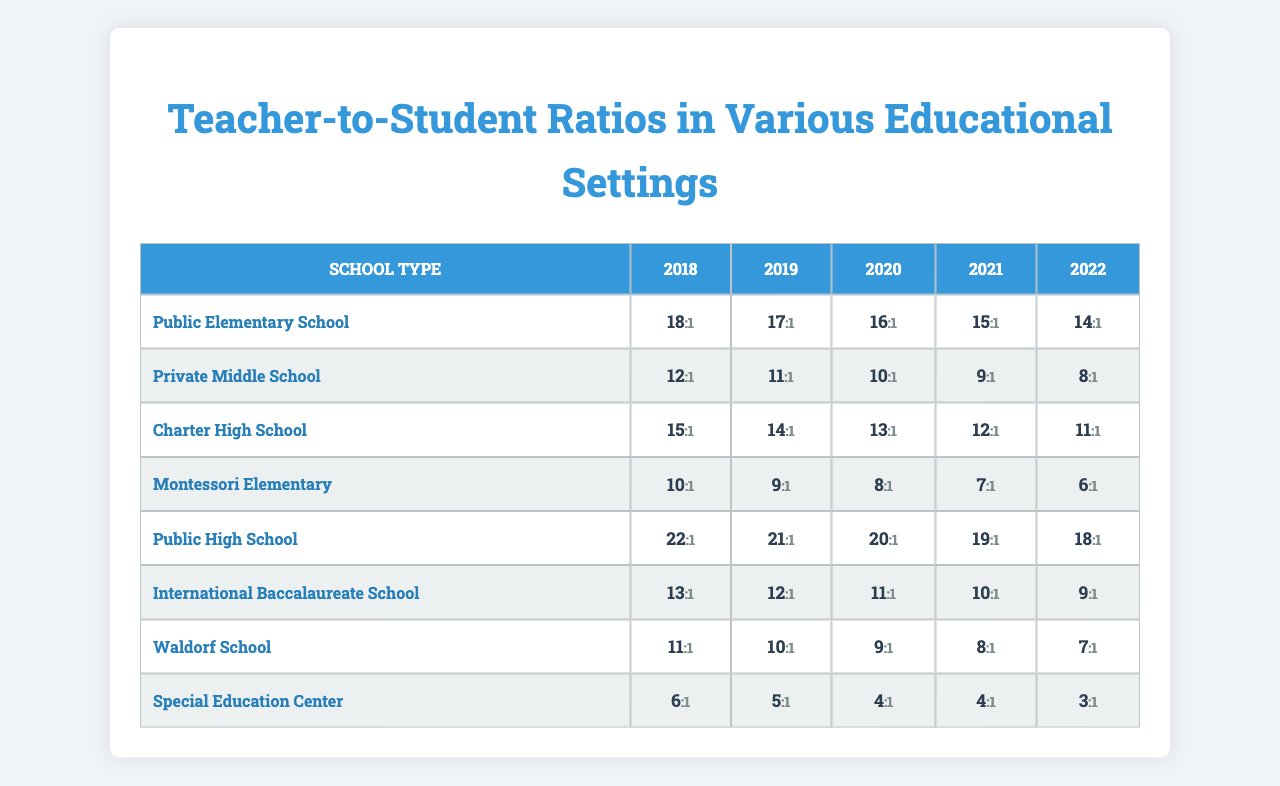What is the teacher-to-student ratio for Public Elementary Schools in 2022? From the table, the ratio for Public Elementary Schools in 2022 is found by looking at the 2022 column for that school type. The value is 14.
Answer: 14 What is the lowest teacher-to-student ratio reported in 2018? To find the lowest ratio in 2018, we look at the first column of ratios for all school types. The lowest value in that column is 6 for the Special Education Center.
Answer: 6 Which school type had the highest teacher-to-student ratio in 2021? In the 2021 column, we compare ratios across all school types. The highest value is 22 for the Public High School.
Answer: Public High School What is the average teacher-to-student ratio for Charter High Schools over the five years? The ratios for Charter High Schools are [15, 14, 13, 12, 11]. We calculate the average by summing these values (15 + 14 + 13 + 12 + 11 = 65) and dividing by the number of years (65/5 = 13).
Answer: 13 Is the teacher-to-student ratio for Montessori Elementary Schools improving from 2018 to 2022? The ratios over the years for Montessori Elementary are [10, 9, 8, 7, 6]. Since the numbers are decreasing each year, this indicates that the ratio is worsening, not improving.
Answer: No What change occurred in the teacher-to-student ratio for Special Education Centers from 2020 to 2022? In 2020, the ratio was 4, and in 2022 it decreased to 3. Thus, the change is a reduction of 1.
Answer: Decrease of 1 Which type of school has consistently maintained the lowest teacher-to-student ratio from 2018 to 2022? By checking the ratios for each school type across the years, Special Education Centers consistently have the lowest ratios of 6, 5, 4, 4, and 3.
Answer: Special Education Center What was the trend in teacher-to-student ratios for Private Middle Schools from 2018 to 2022? The ratios for Private Middle Schools are [12, 11, 10, 9, 8]. The data shows a consistent decrease year by year, which indicates a negative trend.
Answer: Decrease trend What is the difference in the teacher-to-student ratio between the Public High School and Waldorf School in 2022? In 2022, the Public High School has a ratio of 18 and the Waldorf School has a ratio of 7. The difference is 18 - 7 = 11.
Answer: 11 What is the implication of having a lower teacher-to-student ratio? A lower teacher-to-student ratio typically implies more individual attention for each student, which can enhance the learning experience.
Answer: More individual attention 